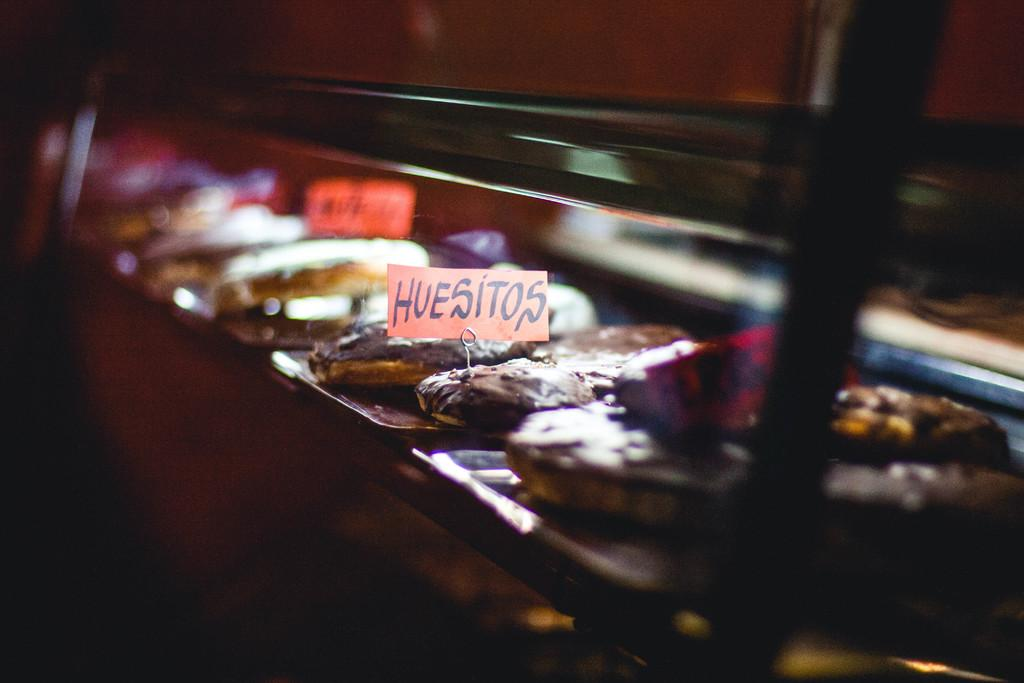What is present in the image that people typically eat? There is food in the image. How are the food items arranged or presented? The food is in plates. What additional objects can be seen in the image? There are boards in the image. What type of trains can be seen passing by in the image? There are no trains present in the image. What is the tendency of the food to move or change position in the image? The food does not have a tendency to move or change position in the image; it is stationary in the plates. 